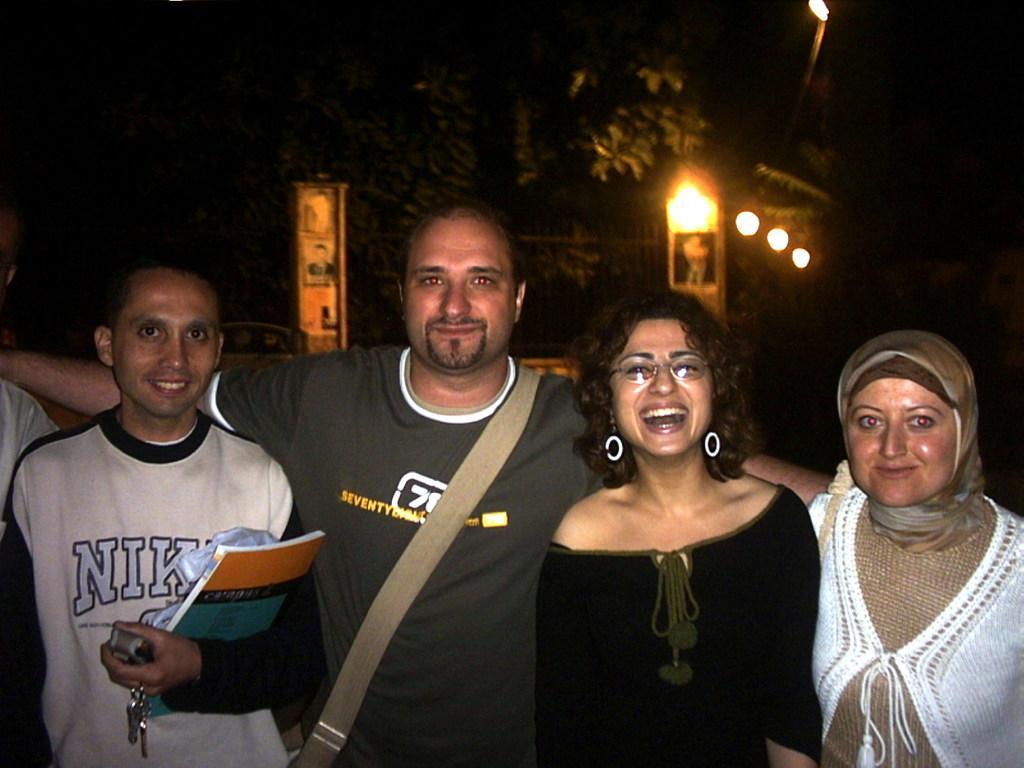Please provide a concise description of this image. This picture contains four people standing in front of the picture. The man on the left corner of the picture is holding books and keys in his hands. Behind them, we see a building and lights. We even see the trees. In the background, it is black in color and this picture is clicked in the dark. 